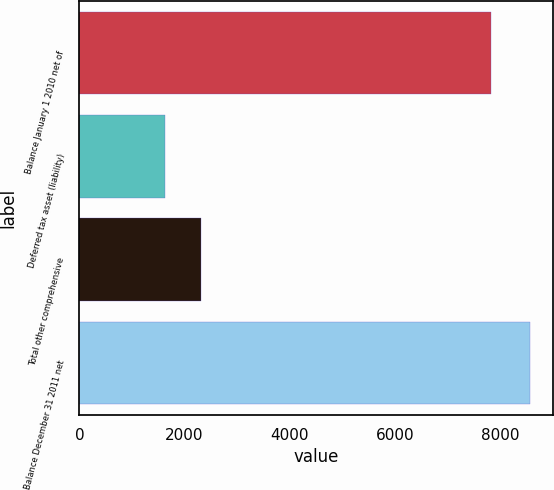Convert chart to OTSL. <chart><loc_0><loc_0><loc_500><loc_500><bar_chart><fcel>Balance January 1 2010 net of<fcel>Deferred tax asset (liability)<fcel>Total other comprehensive<fcel>Balance December 31 2011 net<nl><fcel>7829<fcel>1627<fcel>2321.8<fcel>8575<nl></chart> 